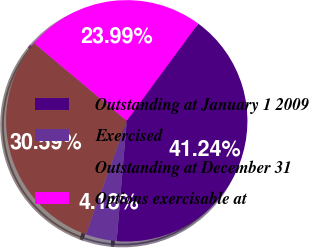Convert chart. <chart><loc_0><loc_0><loc_500><loc_500><pie_chart><fcel>Outstanding at January 1 2009<fcel>Exercised<fcel>Outstanding at December 31<fcel>Options exercisable at<nl><fcel>41.24%<fcel>4.18%<fcel>30.59%<fcel>23.99%<nl></chart> 